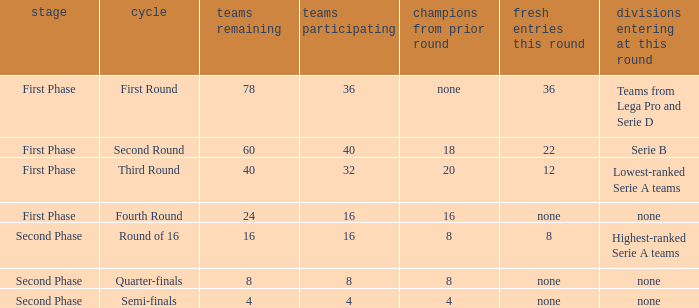Write the full table. {'header': ['stage', 'cycle', 'teams remaining', 'teams participating', 'champions from prior round', 'fresh entries this round', 'divisions entering at this round'], 'rows': [['First Phase', 'First Round', '78', '36', 'none', '36', 'Teams from Lega Pro and Serie D'], ['First Phase', 'Second Round', '60', '40', '18', '22', 'Serie B'], ['First Phase', 'Third Round', '40', '32', '20', '12', 'Lowest-ranked Serie A teams'], ['First Phase', 'Fourth Round', '24', '16', '16', 'none', 'none'], ['Second Phase', 'Round of 16', '16', '16', '8', '8', 'Highest-ranked Serie A teams'], ['Second Phase', 'Quarter-finals', '8', '8', '8', 'none', 'none'], ['Second Phase', 'Semi-finals', '4', '4', '4', 'none', 'none']]} Clubs involved is 8, what number would you find from winners from previous round? 8.0. 